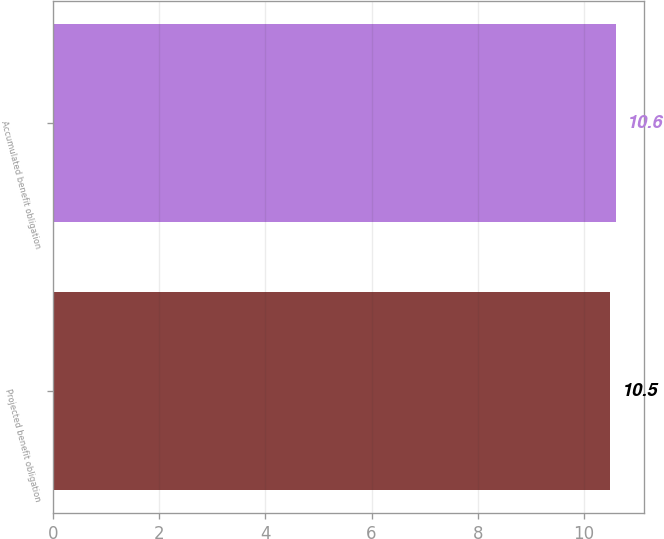Convert chart to OTSL. <chart><loc_0><loc_0><loc_500><loc_500><bar_chart><fcel>Projected benefit obligation<fcel>Accumulated benefit obligation<nl><fcel>10.5<fcel>10.6<nl></chart> 